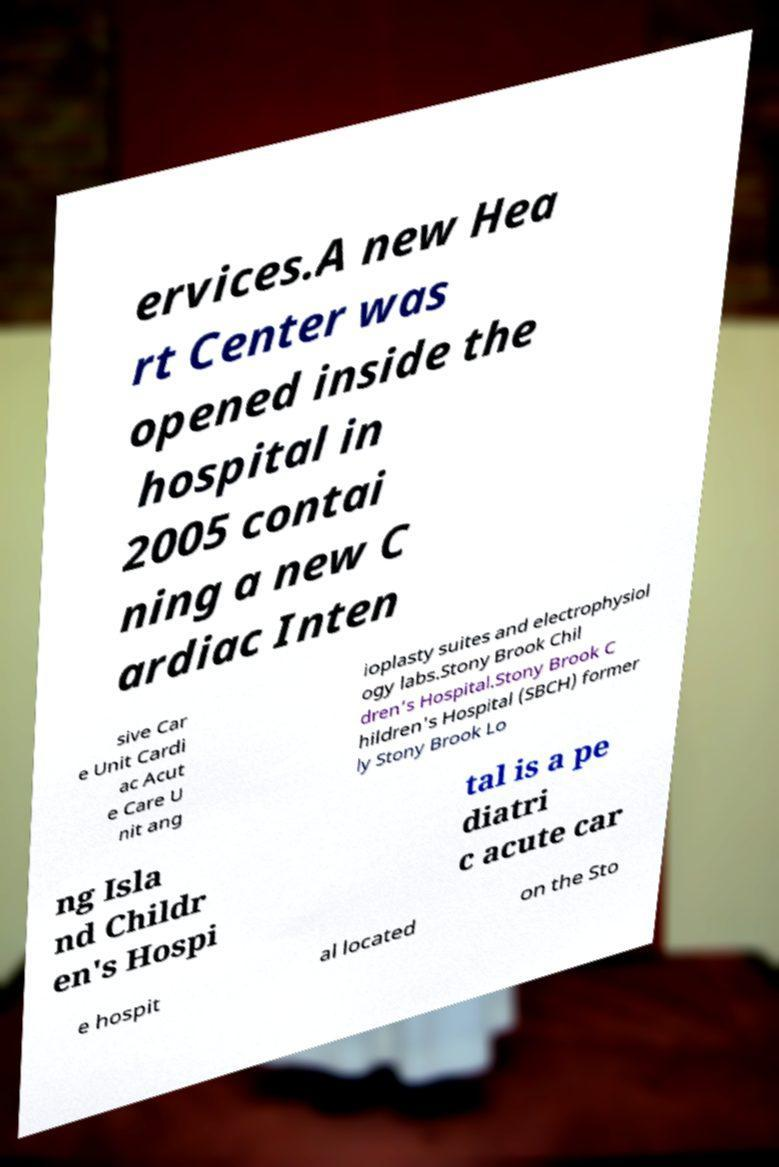I need the written content from this picture converted into text. Can you do that? ervices.A new Hea rt Center was opened inside the hospital in 2005 contai ning a new C ardiac Inten sive Car e Unit Cardi ac Acut e Care U nit ang ioplasty suites and electrophysiol ogy labs.Stony Brook Chil dren’s Hospital.Stony Brook C hildren's Hospital (SBCH) former ly Stony Brook Lo ng Isla nd Childr en's Hospi tal is a pe diatri c acute car e hospit al located on the Sto 